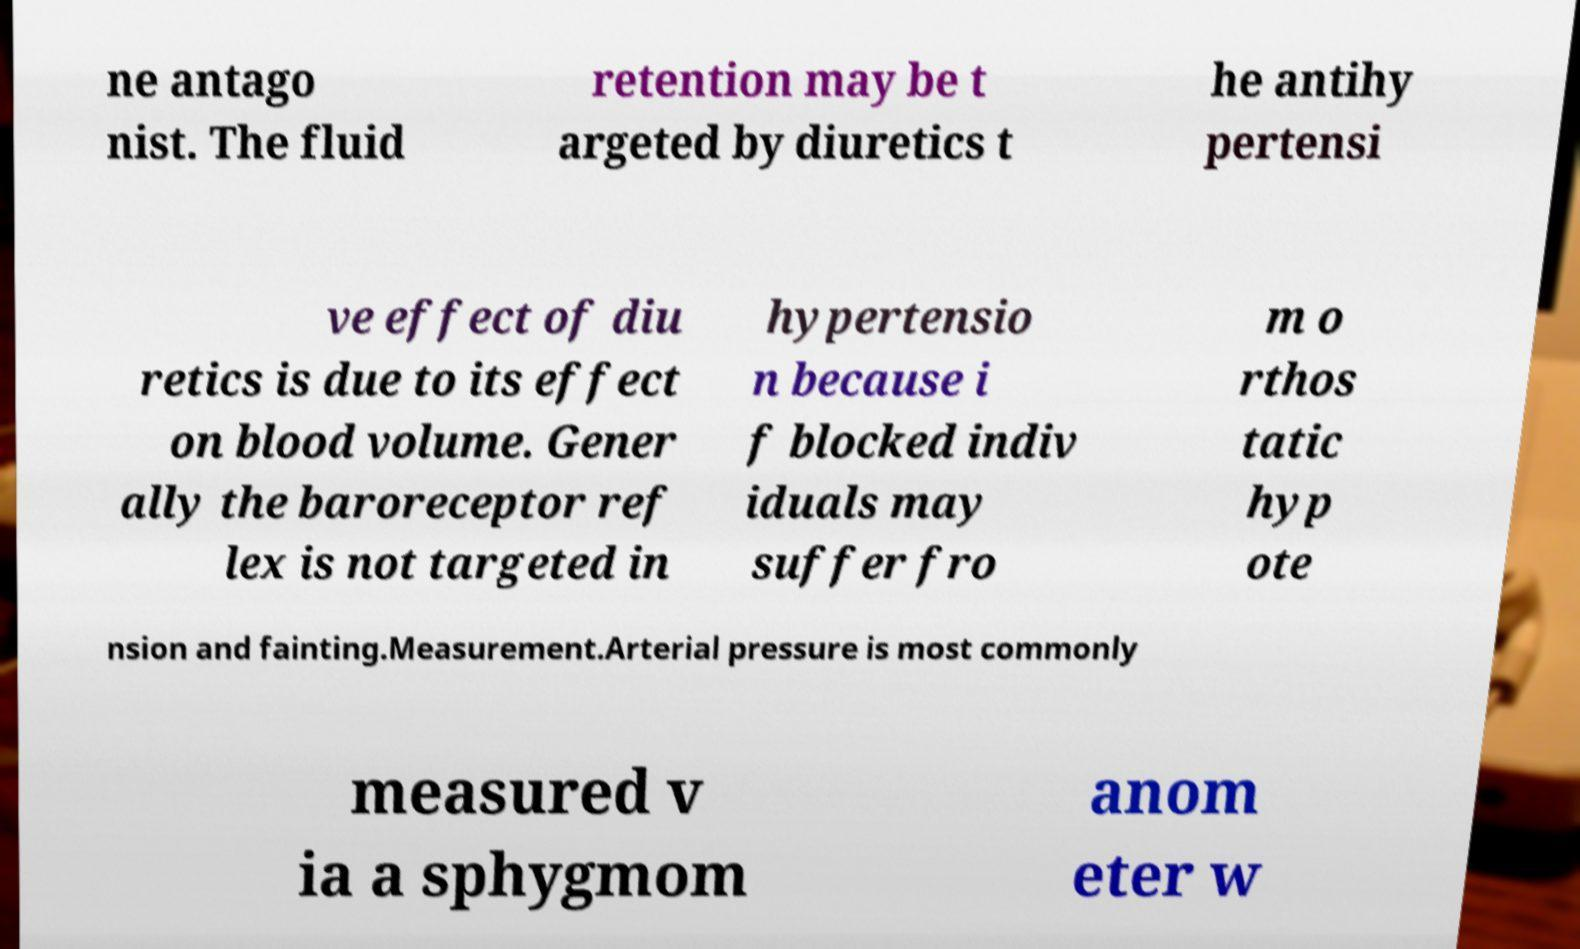Could you assist in decoding the text presented in this image and type it out clearly? ne antago nist. The fluid retention may be t argeted by diuretics t he antihy pertensi ve effect of diu retics is due to its effect on blood volume. Gener ally the baroreceptor ref lex is not targeted in hypertensio n because i f blocked indiv iduals may suffer fro m o rthos tatic hyp ote nsion and fainting.Measurement.Arterial pressure is most commonly measured v ia a sphygmom anom eter w 